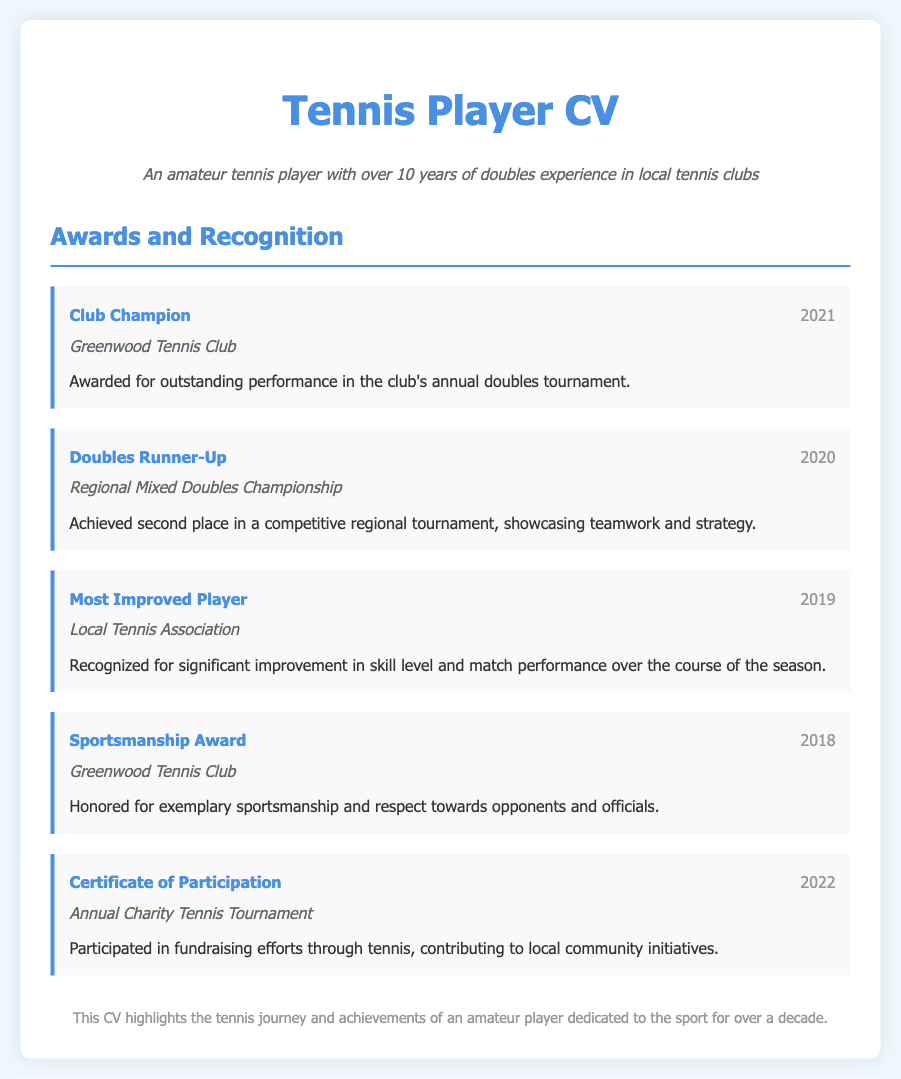What award was received in 2021? The award received in 2021 is mentioned in the document as "Club Champion."
Answer: Club Champion What is the organization for the "Doubles Runner-Up" award? The organization for the "Doubles Runner-Up" award is specified in the document as "Regional Mixed Doubles Championship."
Answer: Regional Mixed Doubles Championship What year did the player receive the "Most Improved Player" award? The year for the "Most Improved Player" award is provided in the document as 2019.
Answer: 2019 How many awards are recorded in the document? The total number of awards is the count of individual award entries listed, which is five.
Answer: 5 What type of award was given in 2018? The type of award given in 2018 is shared in the document as "Sportsmanship Award."
Answer: Sportsmanship Award What achievement is highlighted by the "Certificate of Participation"? The "Certificate of Participation" highlights participation in a charity event, as detailed in the document.
Answer: Annual Charity Tennis Tournament Which award recognizes exemplary behavior towards opponents? The document specifies that the "Sportsmanship Award" recognizes exemplary behavior towards opponents.
Answer: Sportsmanship Award What does the subtitle of the CV indicate about the player's experience? The subtitle describes the player's experience, indicating over 10 years in doubles at local clubs.
Answer: over 10 years 